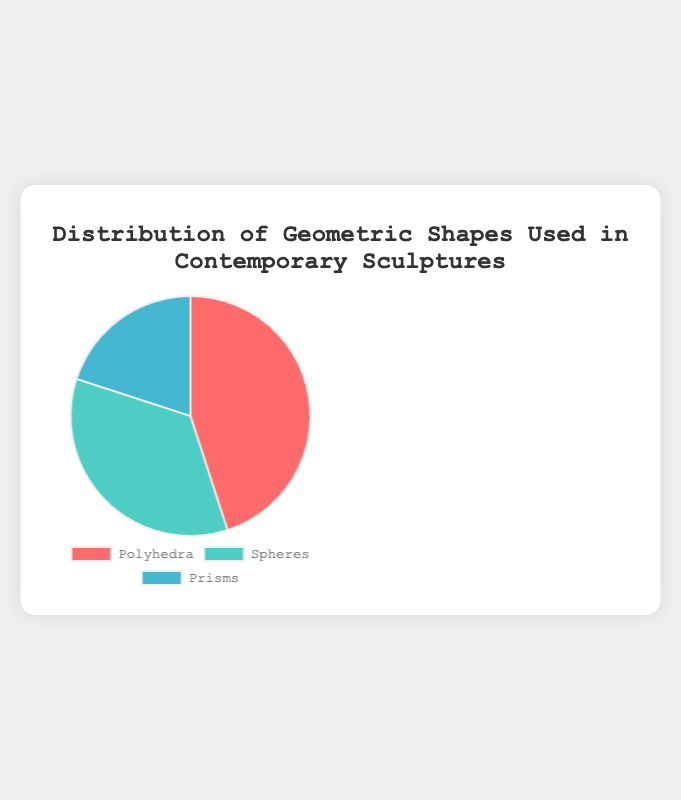What percentage of contemporary sculptures use Polyhedra? Looking at the Pie chart, the section labeled "Polyhedra" indicates its percentage directly.
Answer: 45% Which geometric shape is used the least in contemporary sculptures? Comparing the sizes of the slices in the Pie chart, the smallest section represents the shape with the least percentage. This corresponds to "Prisms" with 20%.
Answer: Prisms Which shape is used more frequently in sculptures, Polyhedra or Spheres? Comparing the sizes of the sections labeled "Polyhedra" and "Spheres," the Polyhedra slice is larger, representing a higher percentage.
Answer: Polyhedra What is the combined percentage of sculptures using either Polyhedra or Prisms? Sum the percentages of Polyhedra and Prisms: 45% + 20% = 65%.
Answer: 65% How much more common are Polyhedra in sculptures compared to Prisms? Subtract the percentage of Prisms from that of Polyhedra: 45% - 20% = 25%.
Answer: 25% Which shape has a larger representation, Spheres or Prisms? By looking at the Pie chart, the section for "Spheres" is larger than that for "Prisms," indicating a higher percentage.
Answer: Spheres What is the proportion of sculptures that do not use Spheres? Subtract the percentage of Spheres from 100%: 100% - 35% = 65%.
Answer: 65% What is the difference between the most and least used geometric shapes in sculptures? Subtract the percentage of the least used shape (Prisms) from the most used shape (Polyhedra): 45% - 20% = 25%.
Answer: 25% If you add the percentages of Spheres and Prisms, is the total greater than the percentage of Polyhedra? Calculate the sum of Spheres and Prisms: 35% + 20% = 55%. Compare it with Polyhedra (45%). Since 55% is greater than 45%, the total is indeed greater.
Answer: Yes 